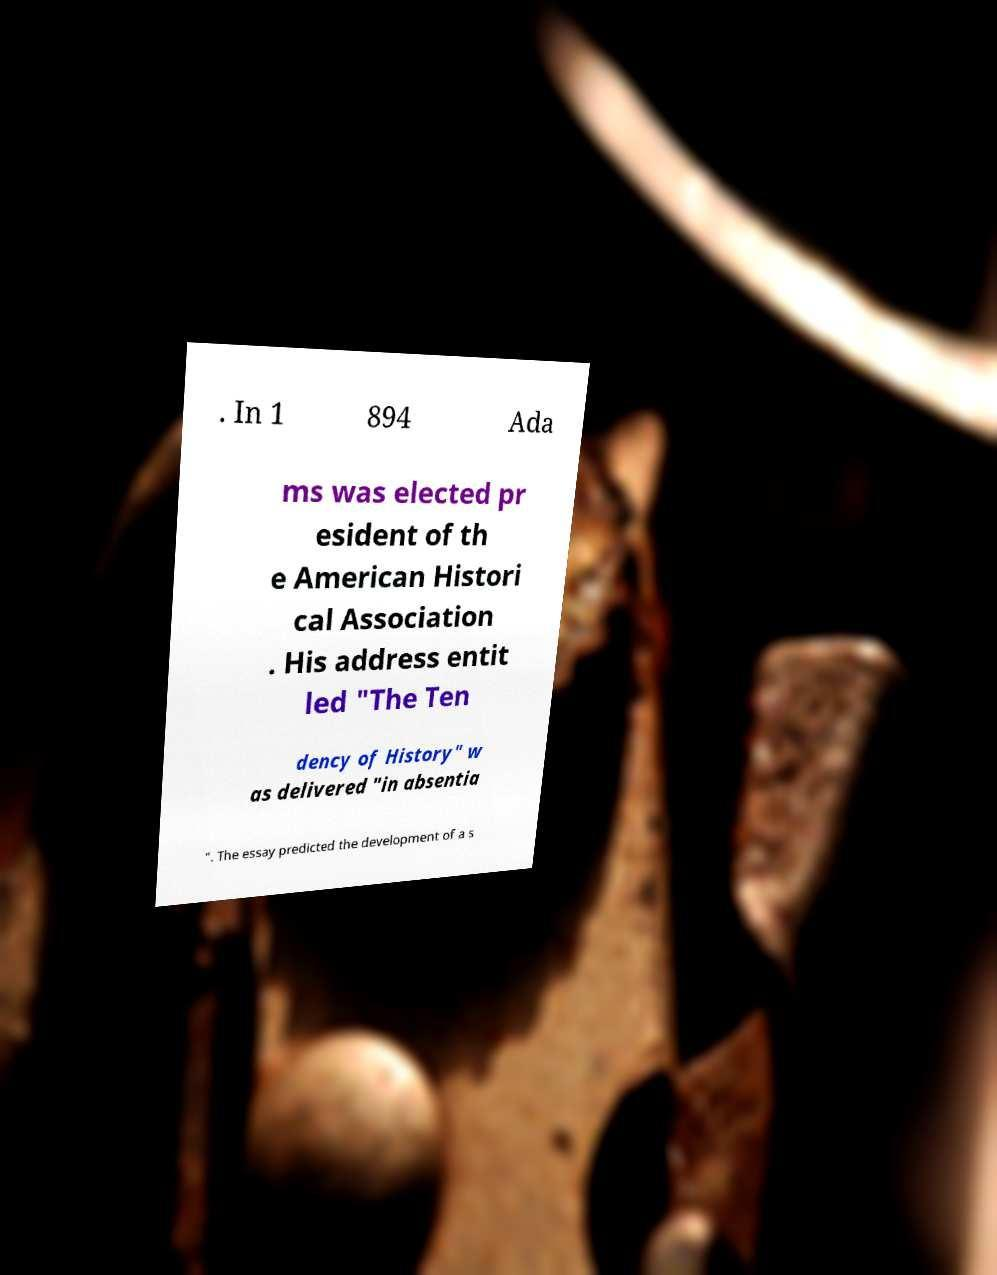For documentation purposes, I need the text within this image transcribed. Could you provide that? . In 1 894 Ada ms was elected pr esident of th e American Histori cal Association . His address entit led "The Ten dency of History" w as delivered "in absentia ". The essay predicted the development of a s 